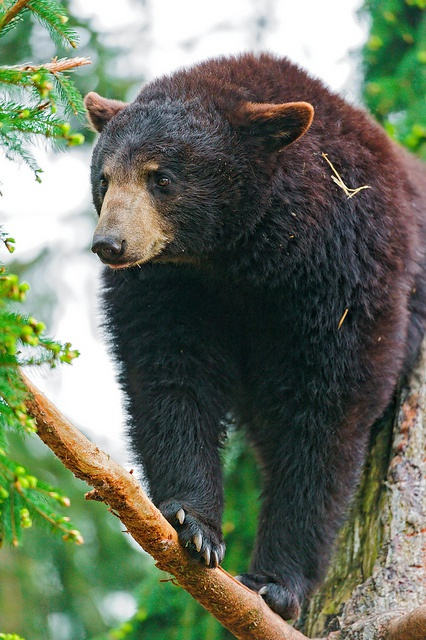Describe the objects in this image and their specific colors. I can see a bear in tan, black, gray, and maroon tones in this image. 